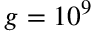Convert formula to latex. <formula><loc_0><loc_0><loc_500><loc_500>g = 1 0 ^ { 9 }</formula> 